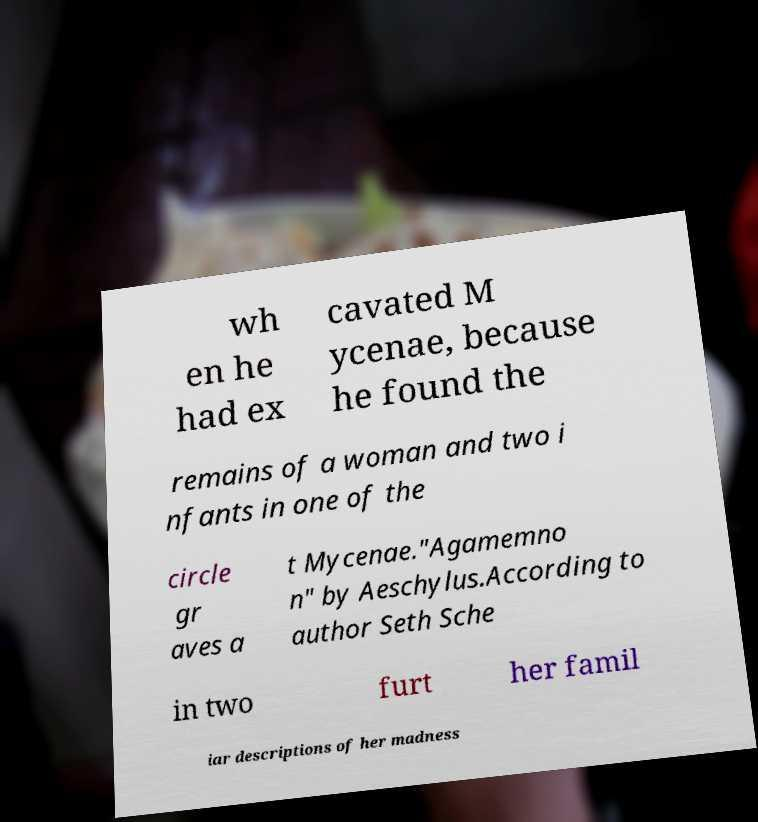I need the written content from this picture converted into text. Can you do that? wh en he had ex cavated M ycenae, because he found the remains of a woman and two i nfants in one of the circle gr aves a t Mycenae."Agamemno n" by Aeschylus.According to author Seth Sche in two furt her famil iar descriptions of her madness 